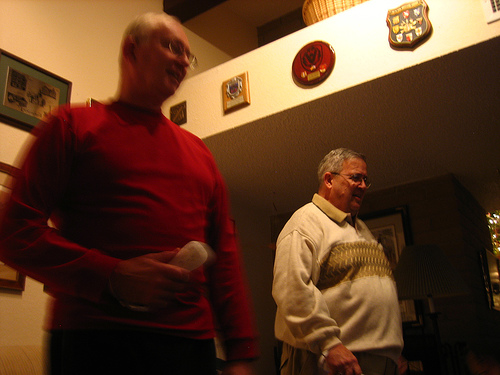What is the device to the left of the guy that is wearing a sweater?
Answer the question using a single word or phrase. Remote control Is the person near the sweater wearing jeans? No Are there any batteries or girls? No Is the shirt below the frame? Yes What is the person to the right of the remote control wearing? Sweater Who is wearing a sweater? Guy Are there both remote controls and beds in the picture? No What kind of device is the man holding? Remote control Do you see a dog next to the person that is holding the remote control? No Who is wearing the sweater? Guy 